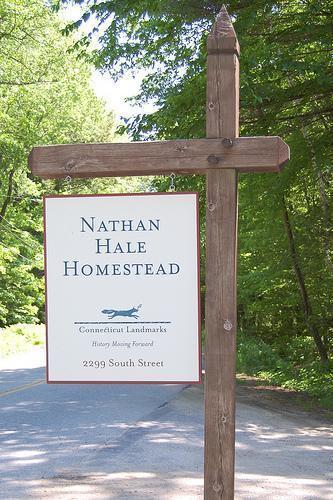How many signs?
Give a very brief answer. 1. 